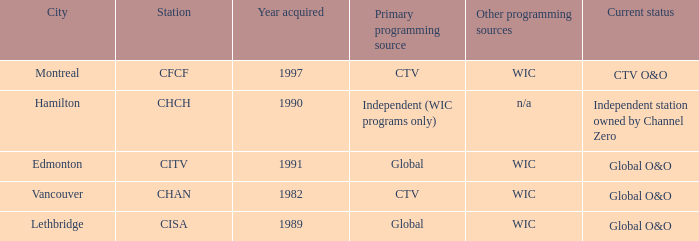How any were gained as the chan 1.0. 